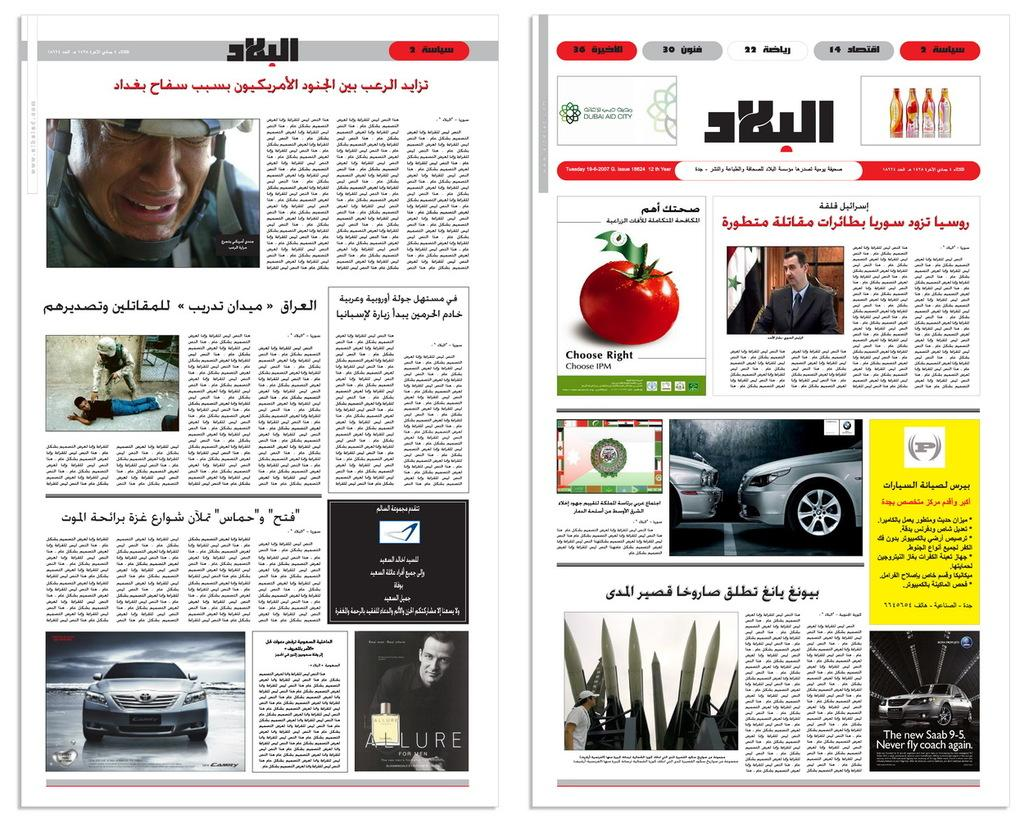What type of publication is the image likely to be? The image is likely a newspaper. What types of images can be found in the newspaper? There are pictures of people, cars, a tomato, and bottles in the newspaper. What else can be found in the newspaper besides images? There are letters in the newspaper. What type of statement can be seen on the train in the image? There is no train present in the image, and therefore no statement can be seen on it. Can you tell me how many popcorn kernels are visible in the image? There is no popcorn present in the image, so it is not possible to determine the number of kernels. 